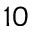<formula> <loc_0><loc_0><loc_500><loc_500>1 0</formula> 